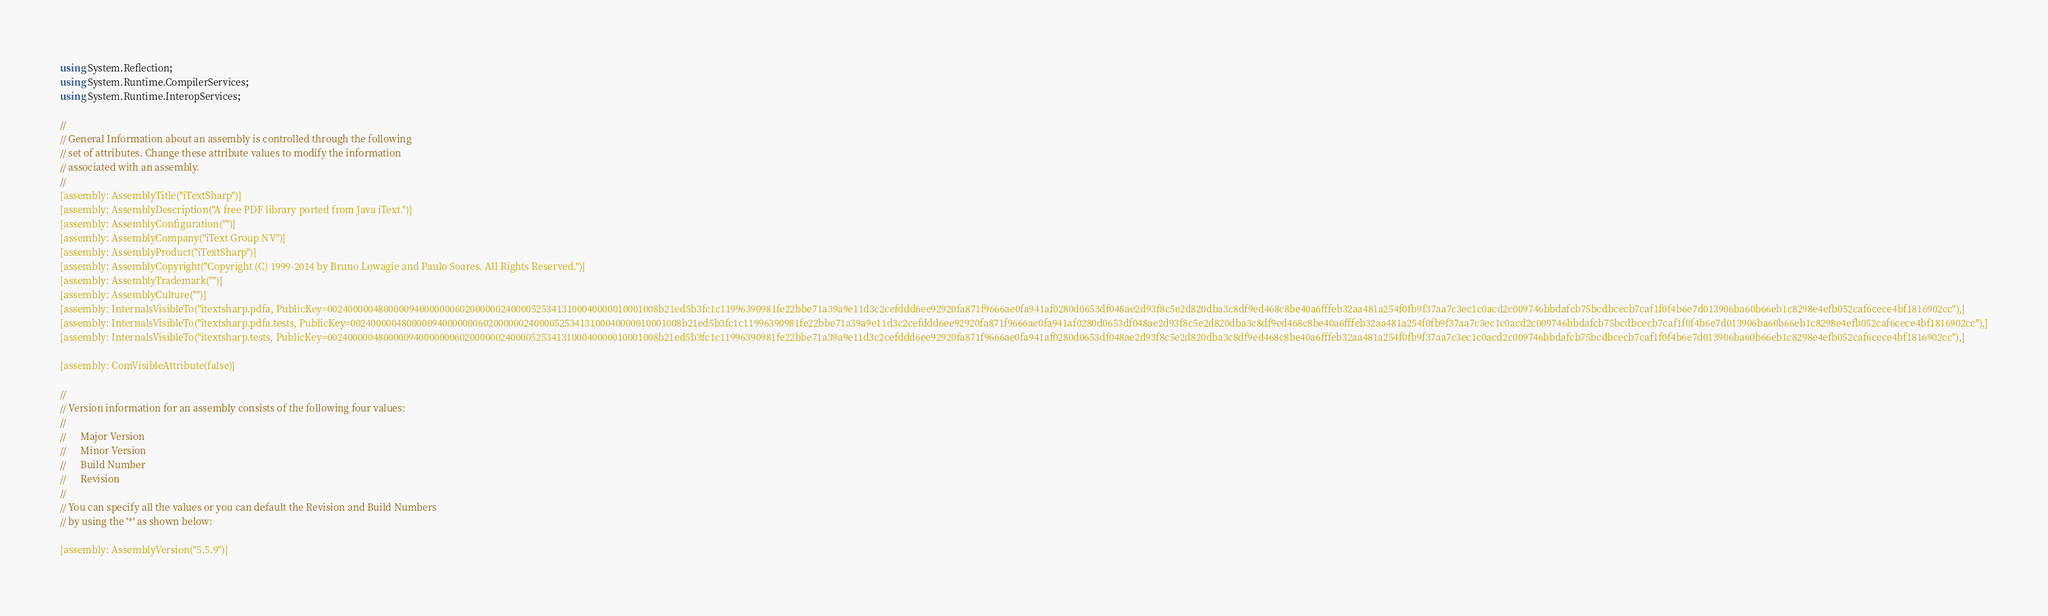Convert code to text. <code><loc_0><loc_0><loc_500><loc_500><_C#_>using System.Reflection;
using System.Runtime.CompilerServices;
using System.Runtime.InteropServices;

//
// General Information about an assembly is controlled through the following 
// set of attributes. Change these attribute values to modify the information
// associated with an assembly.
//
[assembly: AssemblyTitle("iTextSharp")]
[assembly: AssemblyDescription("A free PDF library ported from Java iText.")]
[assembly: AssemblyConfiguration("")]
[assembly: AssemblyCompany("iText Group NV")]
[assembly: AssemblyProduct("iTextSharp")]
[assembly: AssemblyCopyright("Copyright (C) 1999-2014 by Bruno Lowagie and Paulo Soares. All Rights Reserved.")]
[assembly: AssemblyTrademark("")]
[assembly: AssemblyCulture("")]
[assembly: InternalsVisibleTo("itextsharp.pdfa, PublicKey=00240000048000009400000006020000002400005253413100040000010001008b21ed5b3fc1c11996390981fe22bbe71a39a9e11d3c2cefddd6ee92920fa871f9666ae0fa941af0280d0653df048ae2d93f8c5e2d820dba3c8df9ed468c8be40a6fffeb32aa481a254f0fb9f37aa7c3ec1c0acd2c009746bbdafcb75bcdbcecb7caf1f0f4b6e7d013906ba60b66eb1c8298e4efb052caf6cece4bf1816902cc"),]
[assembly: InternalsVisibleTo("itextsharp.pdfa.tests, PublicKey=00240000048000009400000006020000002400005253413100040000010001008b21ed5b3fc1c11996390981fe22bbe71a39a9e11d3c2cefddd6ee92920fa871f9666ae0fa941af0280d0653df048ae2d93f8c5e2d820dba3c8df9ed468c8be40a6fffeb32aa481a254f0fb9f37aa7c3ec1c0acd2c009746bbdafcb75bcdbcecb7caf1f0f4b6e7d013906ba60b66eb1c8298e4efb052caf6cece4bf1816902cc"),]
[assembly: InternalsVisibleTo("itextsharp.tests, PublicKey=00240000048000009400000006020000002400005253413100040000010001008b21ed5b3fc1c11996390981fe22bbe71a39a9e11d3c2cefddd6ee92920fa871f9666ae0fa941af0280d0653df048ae2d93f8c5e2d820dba3c8df9ed468c8be40a6fffeb32aa481a254f0fb9f37aa7c3ec1c0acd2c009746bbdafcb75bcdbcecb7caf1f0f4b6e7d013906ba60b66eb1c8298e4efb052caf6cece4bf1816902cc"),]

[assembly: ComVisibleAttribute(false)]

//
// Version information for an assembly consists of the following four values:
//
//      Major Version
//      Minor Version 
//      Build Number
//      Revision
//
// You can specify all the values or you can default the Revision and Build Numbers 
// by using the '*' as shown below:

[assembly: AssemblyVersion("5.5.9")]
</code> 